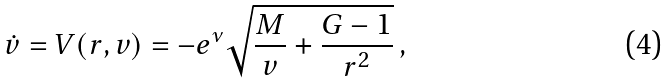Convert formula to latex. <formula><loc_0><loc_0><loc_500><loc_500>\dot { v } = V ( r , v ) = - e ^ { \nu } \sqrt { \frac { M } { v } + \frac { G - 1 } { r ^ { 2 } } } \, ,</formula> 